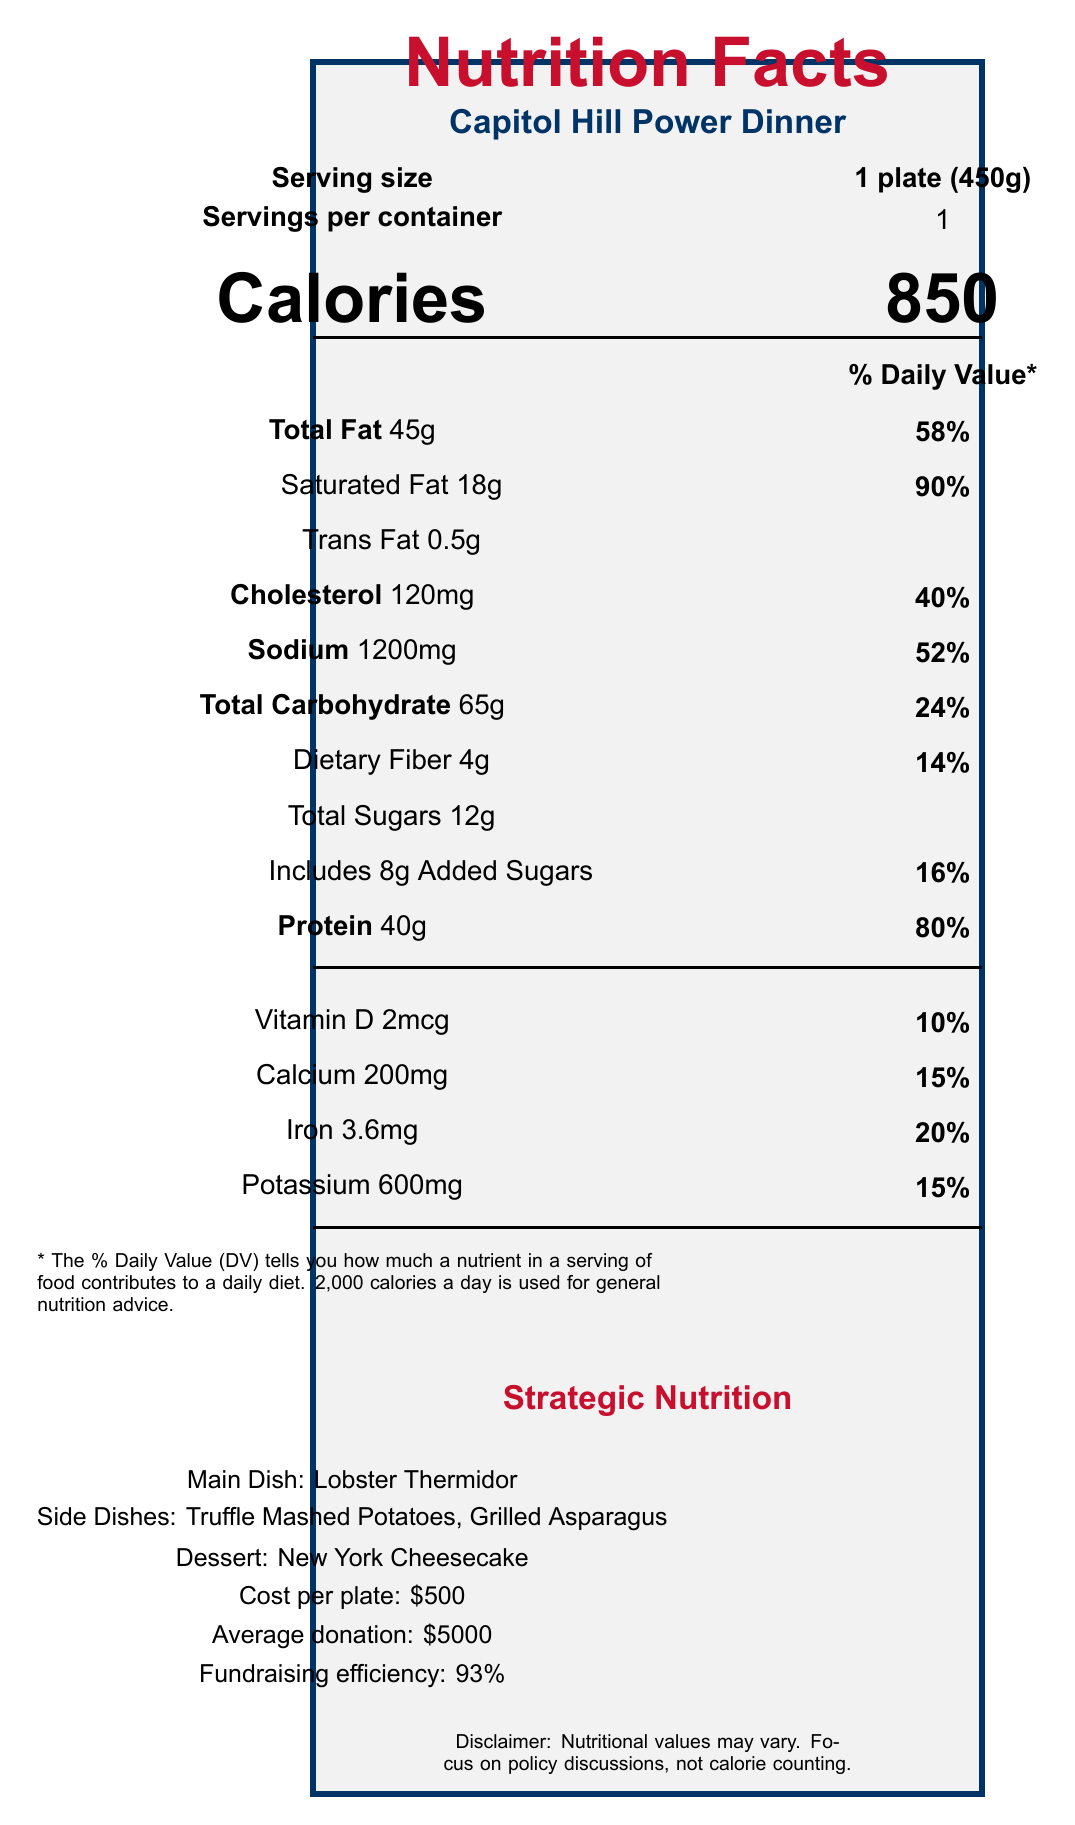What is the serving size for the Capitol Hill Power Dinner? The serving size is explicitly stated as "1 plate (450g)" in the document.
Answer: 1 plate (450g) How much cholesterol is in one serving? The document states that one serving contains 120mg of cholesterol.
Answer: 120mg How much protein does one plate contain? The document specifies that one serving contains 40g of protein.
Answer: 40g What are the side dishes served at the Capitol Hill Power Dinner? The document lists the side dishes as Truffle Mashed Potatoes and Grilled Asparagus.
Answer: Truffle Mashed Potatoes, Grilled Asparagus What is the cost per plate at the Capitol Hill Power Dinner? The document specifies the cost per plate as $500.
Answer: $500 True or False: The beverage choice and its nutritional impact are included in the analysis. The document mentions Champagne as the beverage but states it is "not included in nutritional analysis."
Answer: False Compare the calories in the Capitol Hill Power Dinner to an average American dinner. According to the comparative analysis section, the Capitol Hill Power Dinner has 250 more calories compared to an average American dinner.
Answer: +250 How much daily value of sodium is present in one serving? The document specifies that one serving contains 52% of the daily value of sodium.
Answer: 52% Which main dish is served at the Capitol Hill Power Dinner? The document lists Lobster Thermidor as the main dish.
Answer: Lobster Thermidor Based on the document, what is the perceived sophistication of the Capitol Hill Power Dinner compared to a state fair meal? A. -800% B. +800% C. +1000% D. +500% The comparative analysis section states that the perceived sophistication is +800% compared to a state fair meal.
Answer: B. +800% Which nutrient has the highest percentage of daily value in one serving? A. Sodium B. Total Fat C. Protein D. Saturated Fat The document specifies that saturated fat has a daily value percentage of 90%, which is the highest among the listed nutrients.
Answer: D. Saturated Fat What is the fundraising efficiency of the Capitol Hill Power Dinner in percentage terms? The document states a fundraising efficiency of 93%.
Answer: 93% Does the Capitol Hill Power Dinner include any dietary fiber? If so, how much? The document specifies that one serving includes 4g of dietary fiber.
Answer: Yes, 4g How long are policy discussions scheduled during the event? The document specifies that policy discussion time is 15 minutes.
Answer: 15 minutes How much added sugar is included in one serving? The document notes that one serving includes 8g of added sugars.
Answer: 8g Summarize the main idea of the Capitol Hill Power Dinner document. The document outlines the elements of the Capitol Hill Power Dinner, including nutritional details, cost per plate, comparative analysis with other meals, and strategic notes for political impact and discussions.
Answer: The Capitol Hill Power Dinner is a high-end, bipartisan political fundraising event featuring luxurious dishes like Lobster Thermidor and New York Cheesecake. It boasts high nutritional content and a sophisticated menu aimed at high-net-worth individuals. Additionally, most of the funds raised go directly to campaign efforts. What is the average donation amount per attendee? The document specifies that the average donation is $5000.
Answer: $5000 How does the Capitol Hill Power Dinner compare in sugar content to a state fair meal? The comparative analysis indicates that the Capitol Hill Power Dinner has 30g less sugar compared to a state fair meal.
Answer: -30g Who is the target demographic for the Capitol Hill Power Dinner? The document specifies that the target demographic is high-net-worth individuals and corporate executives.
Answer: High-net-worth individuals and corporate executives What is the art budget for the Capitol Hill Power Dinner? The document does not provide information about the art budget.
Answer: Cannot be determined 